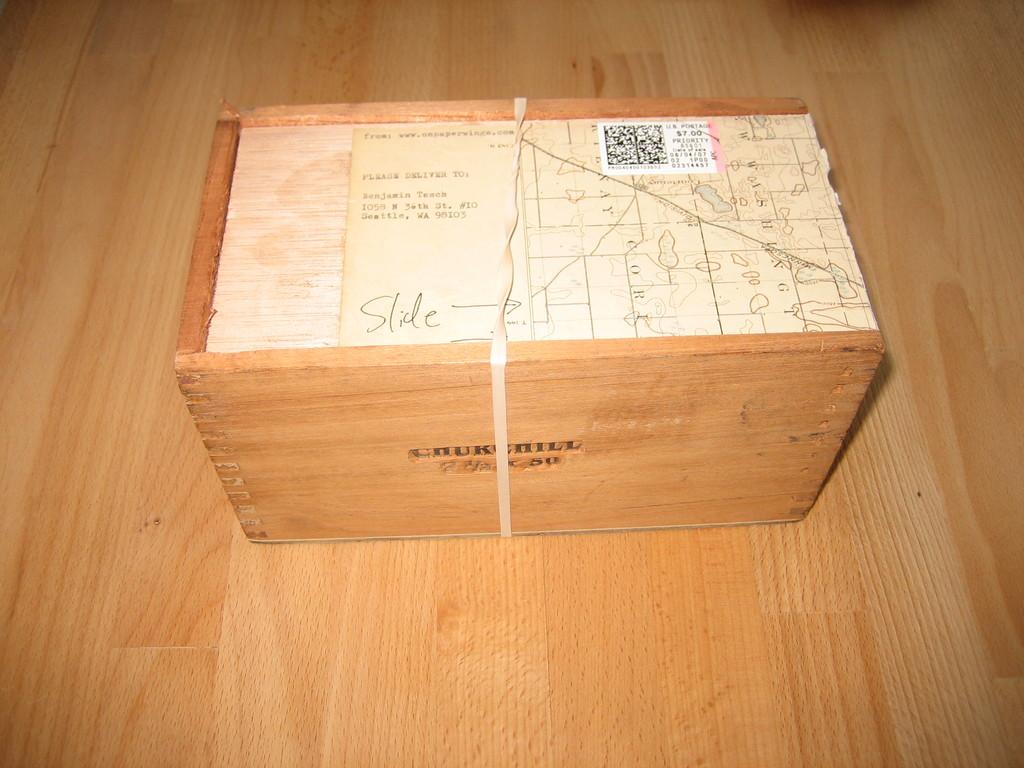What name is mentioned on the envelope?
Provide a succinct answer. Benjamin teach. 